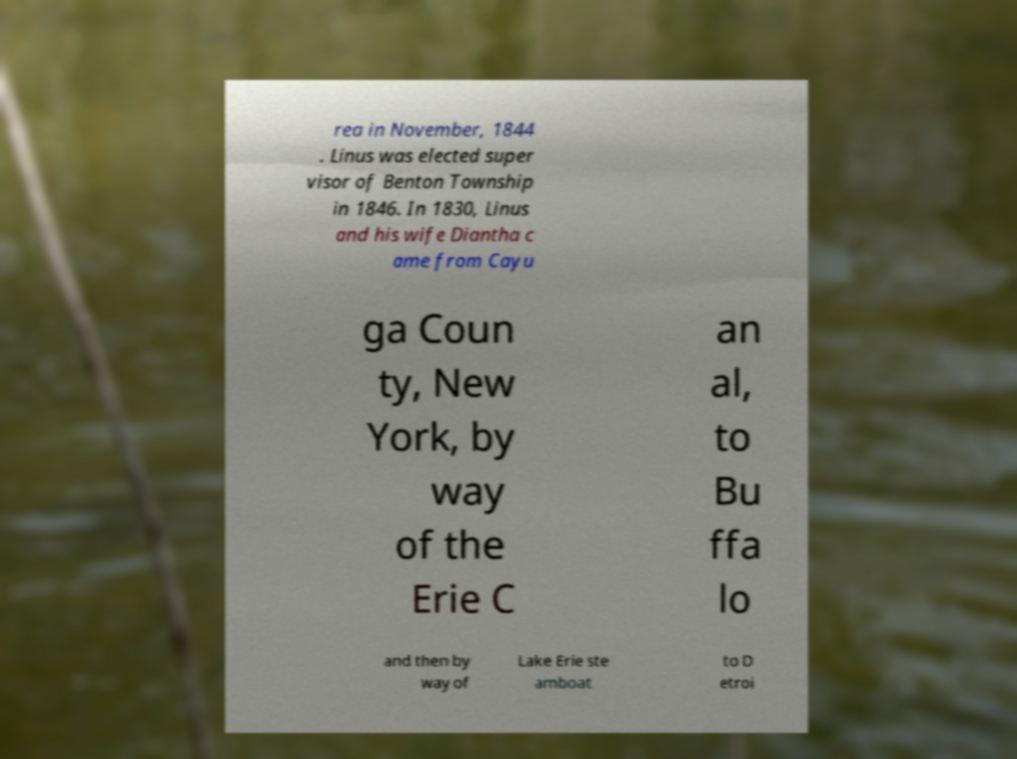What messages or text are displayed in this image? I need them in a readable, typed format. rea in November, 1844 . Linus was elected super visor of Benton Township in 1846. In 1830, Linus and his wife Diantha c ame from Cayu ga Coun ty, New York, by way of the Erie C an al, to Bu ffa lo and then by way of Lake Erie ste amboat to D etroi 